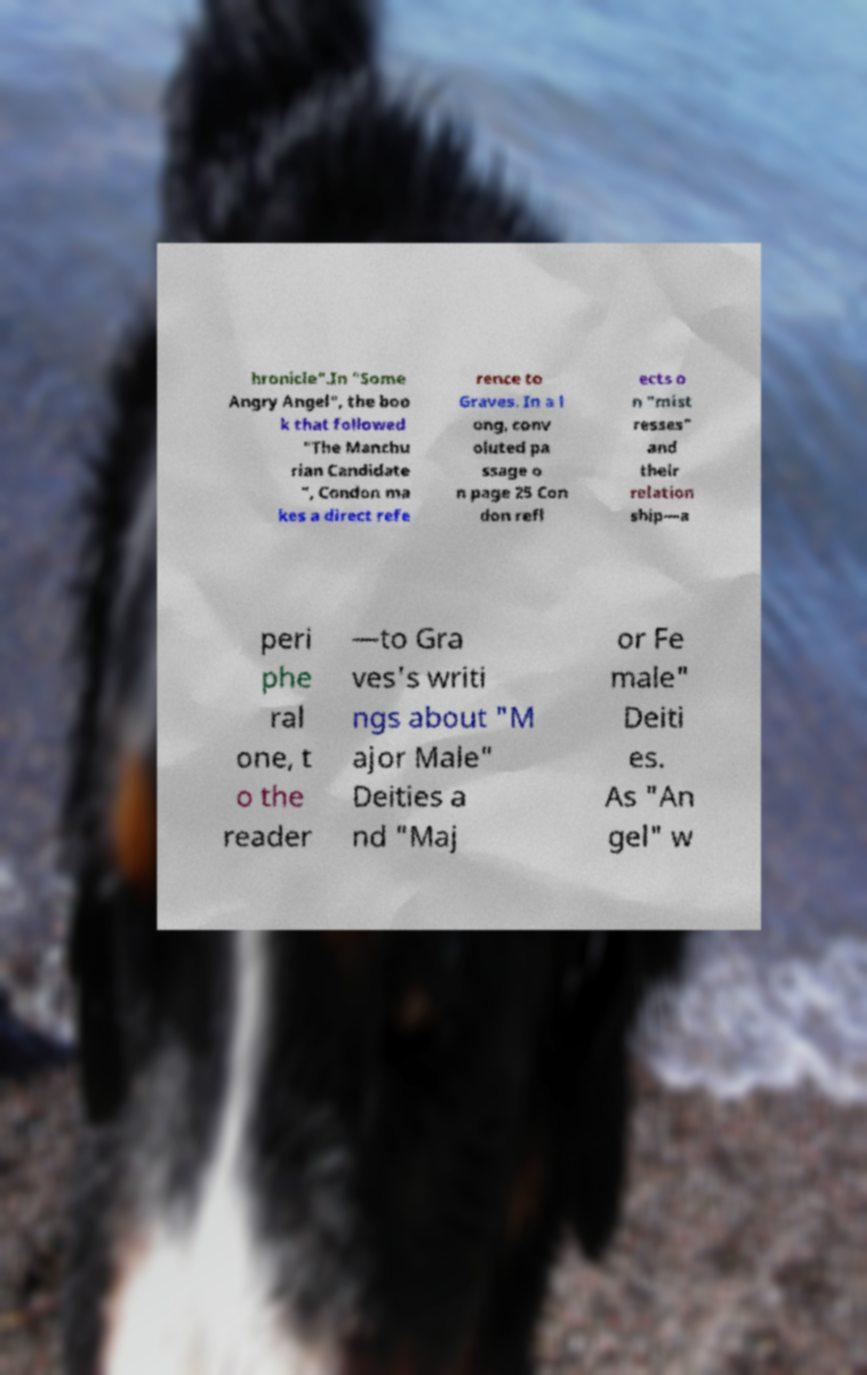For documentation purposes, I need the text within this image transcribed. Could you provide that? hronicle".In "Some Angry Angel", the boo k that followed "The Manchu rian Candidate ", Condon ma kes a direct refe rence to Graves. In a l ong, conv oluted pa ssage o n page 25 Con don refl ects o n "mist resses" and their relation ship—a peri phe ral one, t o the reader —to Gra ves's writi ngs about "M ajor Male" Deities a nd "Maj or Fe male" Deiti es. As "An gel" w 